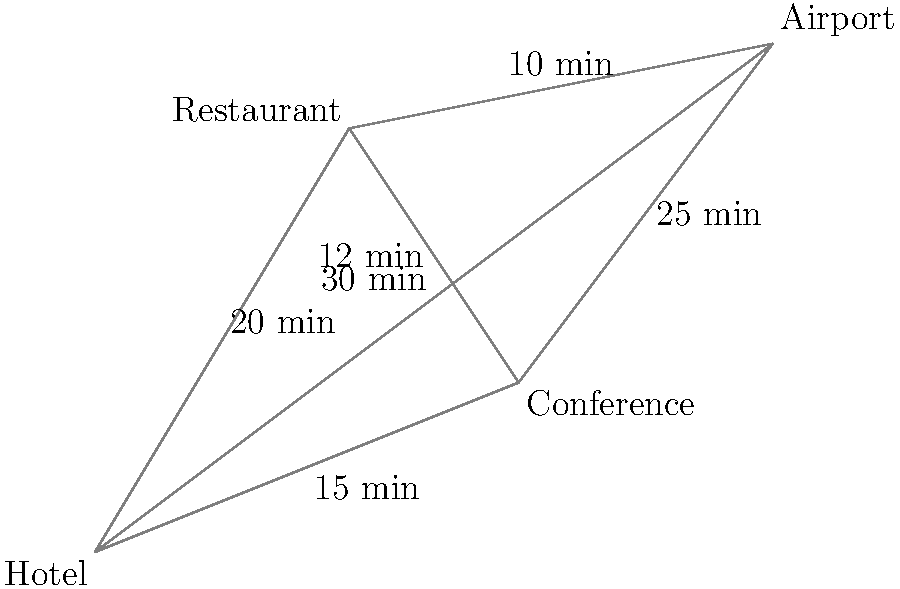A business traveler needs to go from the Hotel to the Conference and then to the Airport for a flight. What is the fastest route and total travel time? To find the fastest route and total travel time, we need to consider all possible paths from the Hotel to the Conference and then to the Airport. Let's break it down step-by-step:

1. Direct route:
   Hotel → Conference (15 min)
   Conference → Airport (25 min)
   Total: 15 + 25 = 40 minutes

2. Route via Restaurant:
   Hotel → Restaurant (20 min)
   Restaurant → Conference (12 min)
   Conference → Airport (25 min)
   Total: 20 + 12 + 25 = 57 minutes

3. Alternative route via Restaurant:
   Hotel → Restaurant (20 min)
   Restaurant → Airport (10 min)
   Total: 20 + 10 = 30 minutes
   However, this route skips the Conference, so it's not valid.

4. Route Hotel → Airport → Conference → Airport:
   Hotel → Airport (30 min)
   Airport → Conference (25 min)
   Conference → Airport (25 min)
   Total: 30 + 25 + 25 = 80 minutes

Comparing the valid routes, we can see that the direct route (Hotel → Conference → Airport) is the fastest, with a total travel time of 40 minutes.
Answer: Hotel → Conference → Airport, 40 minutes 